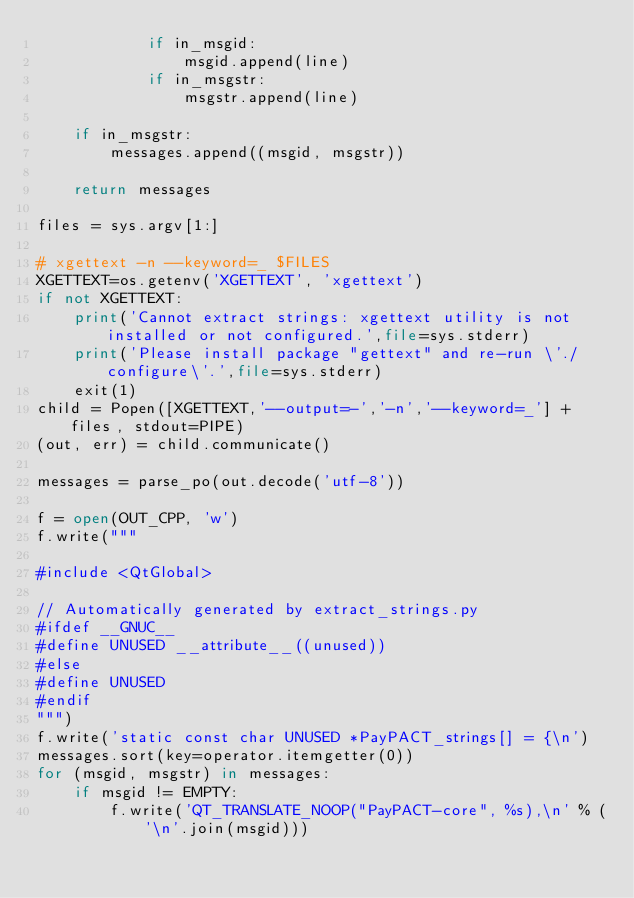<code> <loc_0><loc_0><loc_500><loc_500><_Python_>            if in_msgid:
                msgid.append(line)
            if in_msgstr:
                msgstr.append(line)

    if in_msgstr:
        messages.append((msgid, msgstr))

    return messages

files = sys.argv[1:]

# xgettext -n --keyword=_ $FILES
XGETTEXT=os.getenv('XGETTEXT', 'xgettext')
if not XGETTEXT:
    print('Cannot extract strings: xgettext utility is not installed or not configured.',file=sys.stderr)
    print('Please install package "gettext" and re-run \'./configure\'.',file=sys.stderr)
    exit(1)
child = Popen([XGETTEXT,'--output=-','-n','--keyword=_'] + files, stdout=PIPE)
(out, err) = child.communicate()

messages = parse_po(out.decode('utf-8'))

f = open(OUT_CPP, 'w')
f.write("""

#include <QtGlobal>

// Automatically generated by extract_strings.py
#ifdef __GNUC__
#define UNUSED __attribute__((unused))
#else
#define UNUSED
#endif
""")
f.write('static const char UNUSED *PayPACT_strings[] = {\n')
messages.sort(key=operator.itemgetter(0))
for (msgid, msgstr) in messages:
    if msgid != EMPTY:
        f.write('QT_TRANSLATE_NOOP("PayPACT-core", %s),\n' % ('\n'.join(msgid)))</code> 